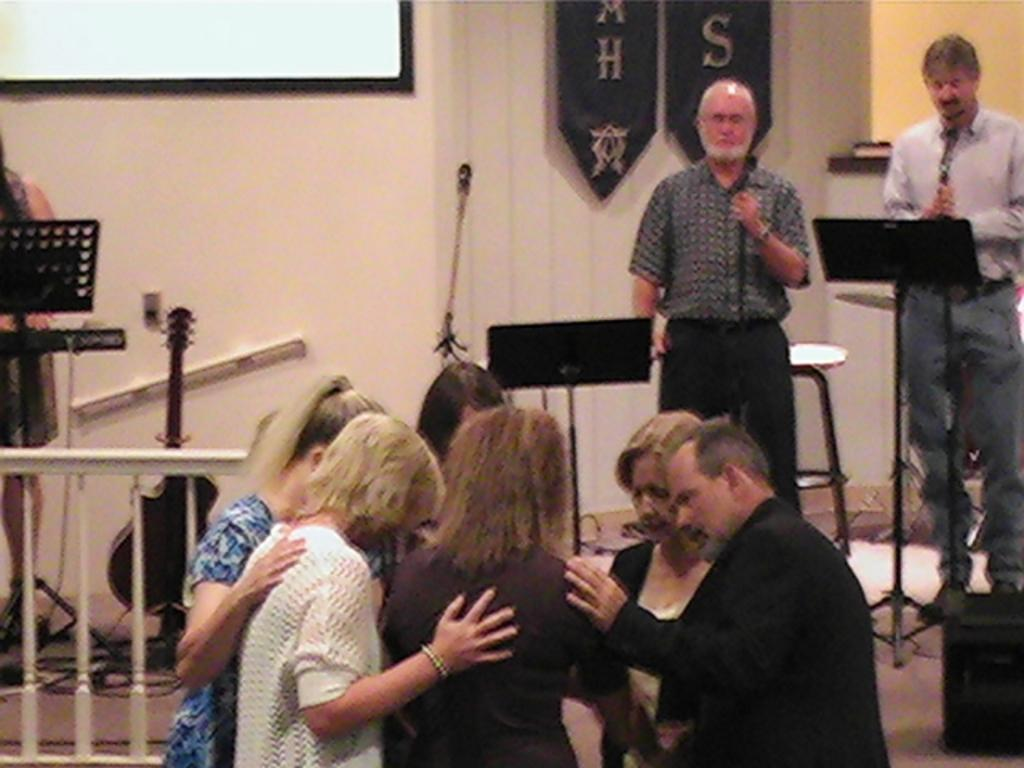What are the people in the image doing? The persons standing on the floor are likely performing or participating in an event. What can be seen in the background of the image? In the background, there are musical instruments, lecterns, mics, walls, an iron grill, and wall hangings. Can you describe the musical instruments in the background? Unfortunately, the specific types of musical instruments cannot be determined from the provided facts. What type of dolls are being used as evidence in the image? There are no dolls present in the image. 